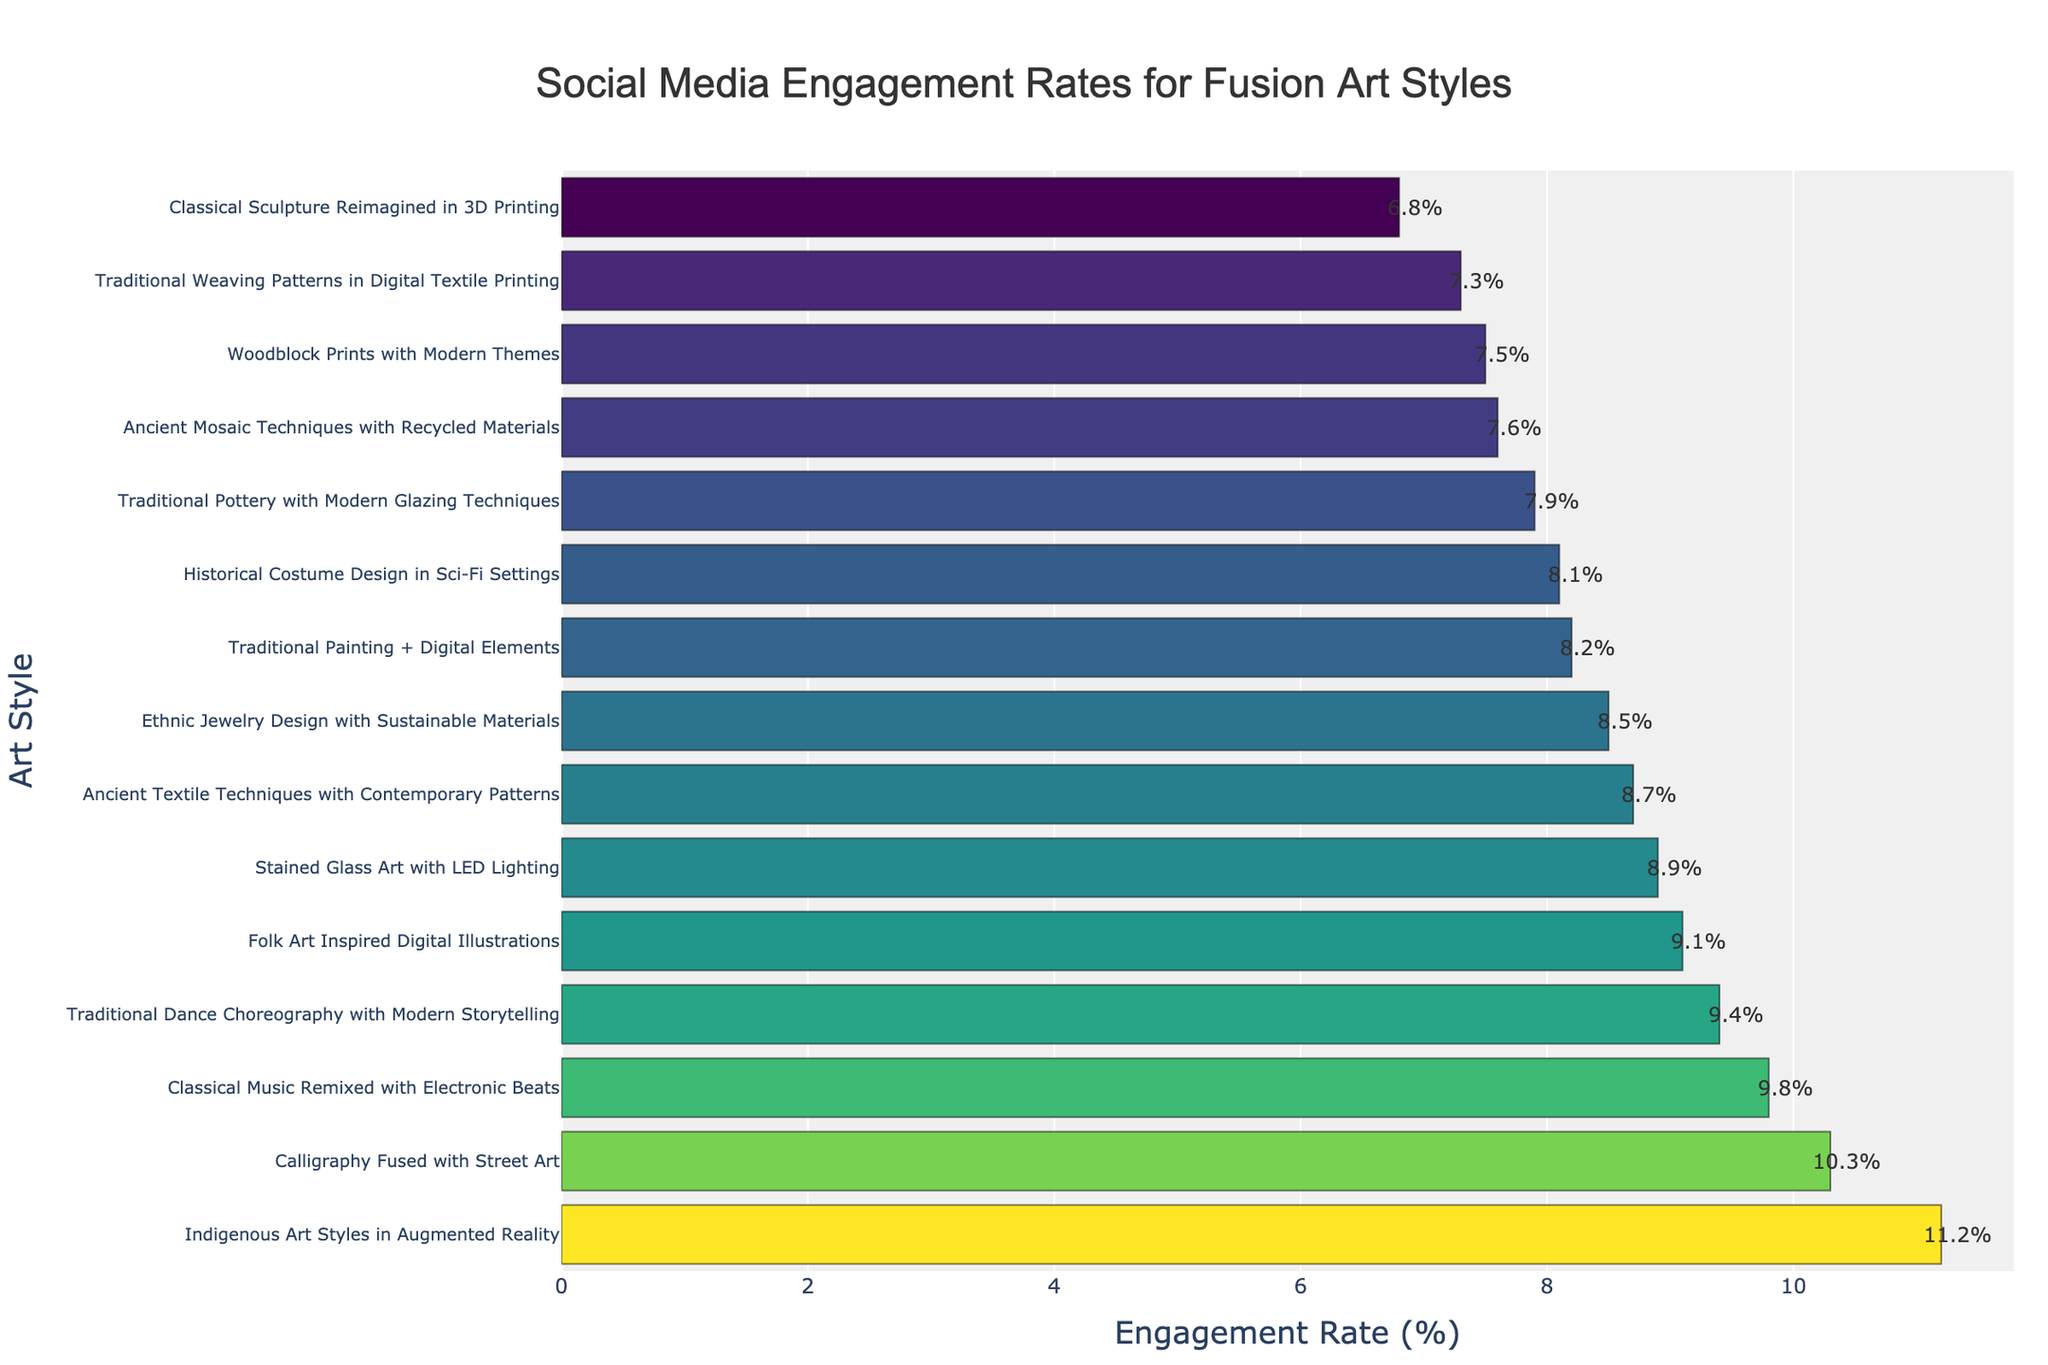Which art style has the highest engagement rate? The highest engagement rate is indicated by the tallest bar in the chart. "Indigenous Art Styles in Augmented Reality" has the highest bar.
Answer: Indigenous Art Styles in Augmented Reality How much higher is the engagement rate of "Calligraphy Fused with Street Art" compared to "Traditional Pottery with Modern Glazing Techniques"? Look at the engagement rates of both styles. Calculate the difference: 10.3% - 7.9%.
Answer: 2.4% Which art style has less than 8% engagement rate? Identify the bars with heights representing values less than 8%. The styles are "Classical Sculpture Reimagined in 3D Printing," "Ancient Mosaic Techniques with Recycled Materials," and "Traditional Weaving Patterns in Digital Textile Printing."
Answer: Classical Sculpture Reimagined in 3D Printing, Ancient Mosaic Techniques with Recycled Materials, Traditional Weaving Patterns in Digital Textile Printing What is the median engagement rate of all the art styles? List all engagement rates in ascending order and find the middle value. The sorted rates are: 6.8%, 7.3%, 7.5%, 7.6%, 7.9%, 8.1%, 8.2%, 8.5%, 8.7%, 8.9%, 9.1%, 9.4%, 9.8%, 10.3%, 11.2%. The middle value is 8.5%.
Answer: 8.5% Which art styles are above the average engagement rate? First, calculate the average engagement rate (sum of all rates divided by the number of styles). The sum is 138.3%, with 15 styles, so the average is 9.22%. Then identify styles above this rate.
Answer: Folk Art Inspired Digital Illustrations, Calligraphy Fused with Street Art, Classical Music Remixed with Electronic Beats, Indigenous Art Styles in Augmented Reality, Traditional Dance Choreography with Modern Storytelling What is the color gradient significance in the bars? The color gradient indicates the engagement rate, with different shades representing varying rates. Darker shades are higher engagement rates, and lighter shades are lower engagement rates.
Answer: Higher engagement rates have darker shades, lower engagement rates have lighter shades 